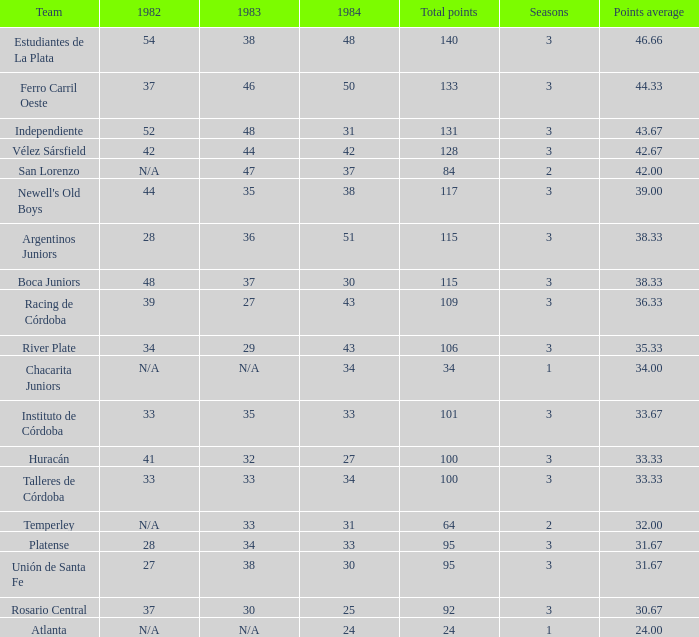In 1984, which team had 3 seasons with under 27? Rosario Central. 